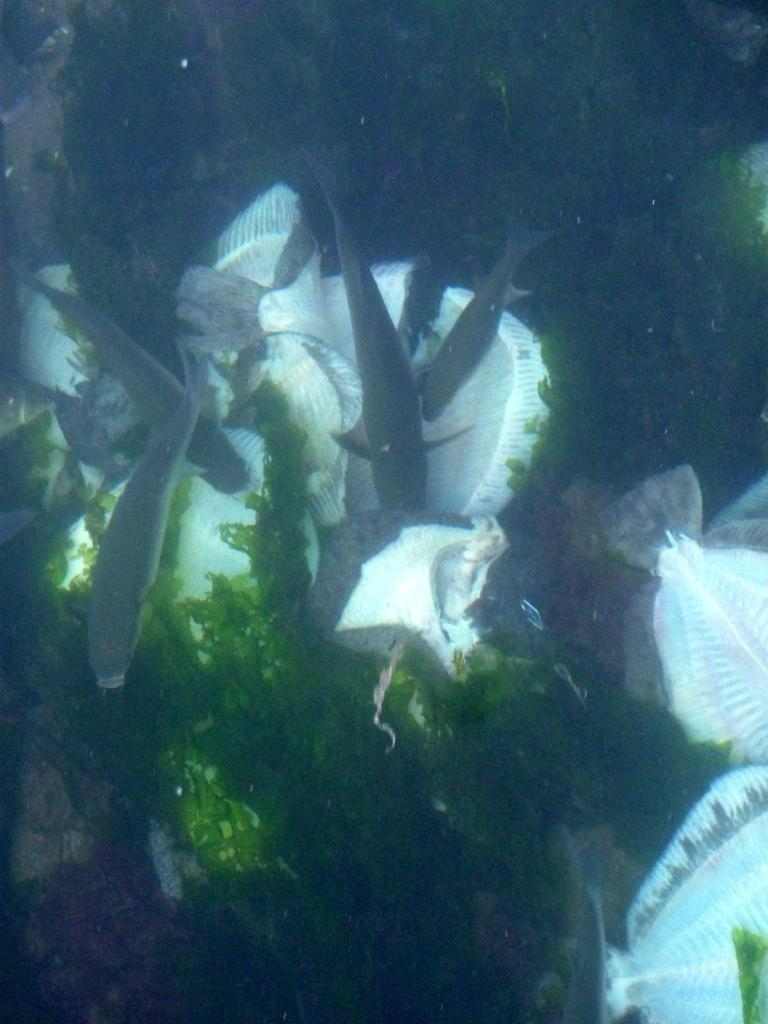What type of environment is shown in the image? The image depicts an underwater environment. What can be seen growing in the underwater environment? There are plants visible in the image. What type of animals can be seen in the image? There are fishes in the image. How many pizzas can be seen floating in the underwater environment? There are no pizzas present in the underwater environment depicted in the image. 